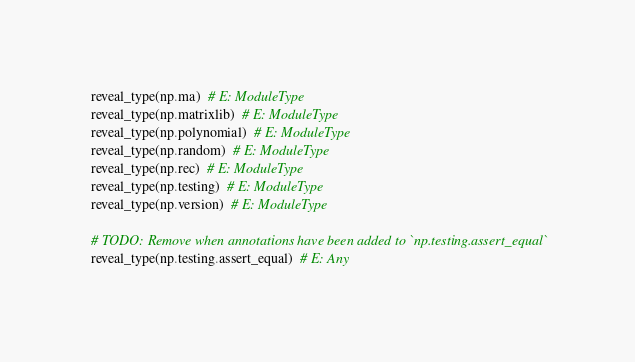<code> <loc_0><loc_0><loc_500><loc_500><_Python_>reveal_type(np.ma)  # E: ModuleType
reveal_type(np.matrixlib)  # E: ModuleType
reveal_type(np.polynomial)  # E: ModuleType
reveal_type(np.random)  # E: ModuleType
reveal_type(np.rec)  # E: ModuleType
reveal_type(np.testing)  # E: ModuleType
reveal_type(np.version)  # E: ModuleType

# TODO: Remove when annotations have been added to `np.testing.assert_equal`
reveal_type(np.testing.assert_equal)  # E: Any
</code> 